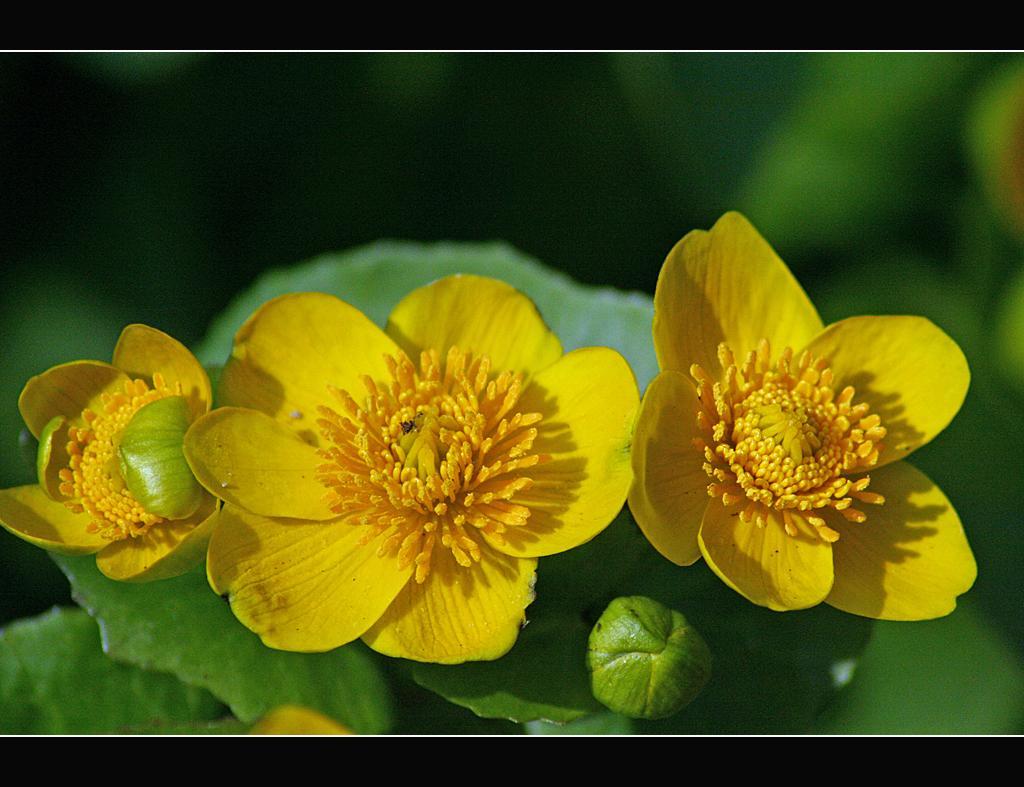In one or two sentences, can you explain what this image depicts? There are yellow color flowers, leaves and a bud. In the background it is blurred. 